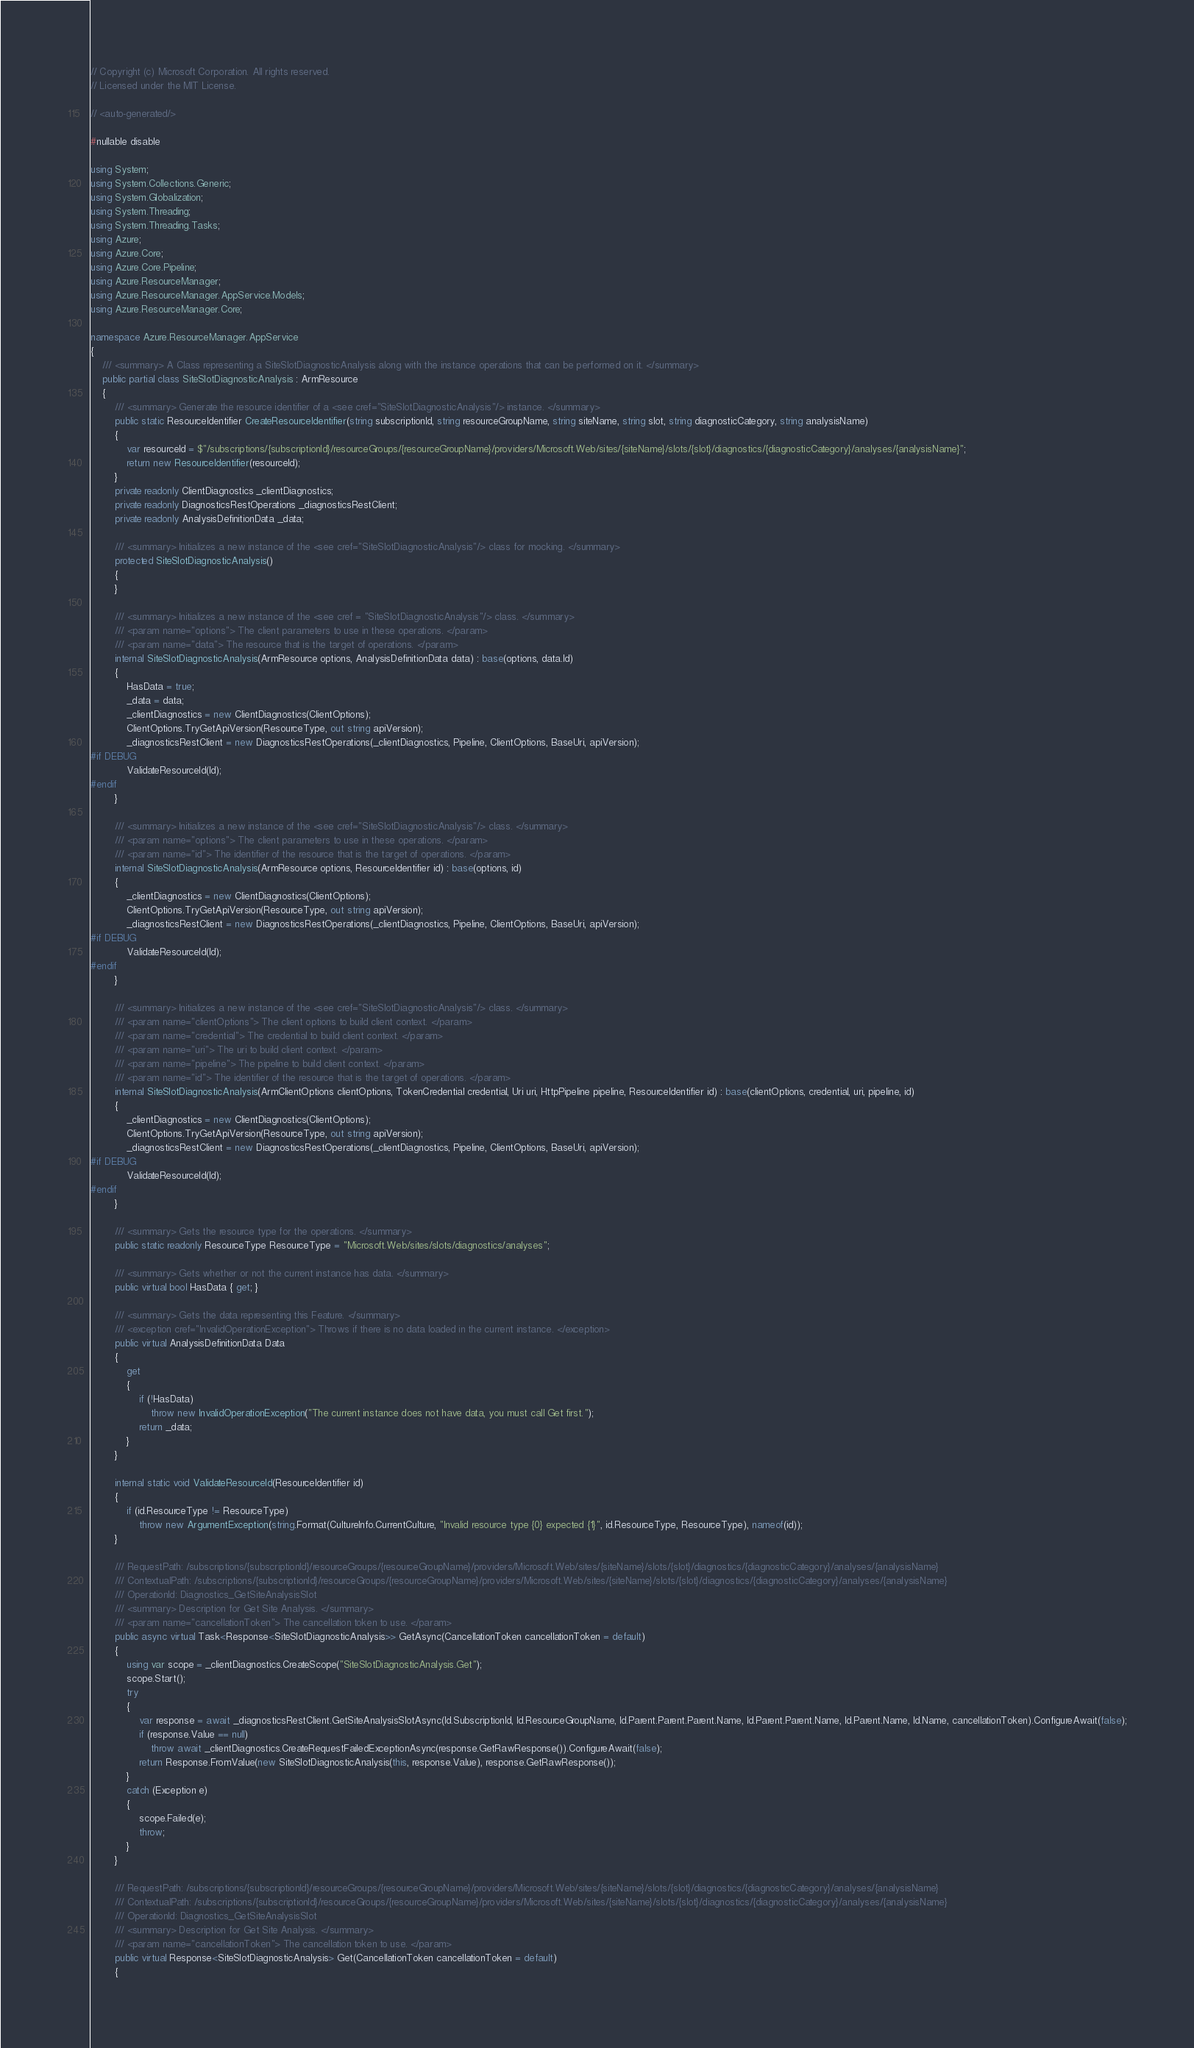<code> <loc_0><loc_0><loc_500><loc_500><_C#_>// Copyright (c) Microsoft Corporation. All rights reserved.
// Licensed under the MIT License.

// <auto-generated/>

#nullable disable

using System;
using System.Collections.Generic;
using System.Globalization;
using System.Threading;
using System.Threading.Tasks;
using Azure;
using Azure.Core;
using Azure.Core.Pipeline;
using Azure.ResourceManager;
using Azure.ResourceManager.AppService.Models;
using Azure.ResourceManager.Core;

namespace Azure.ResourceManager.AppService
{
    /// <summary> A Class representing a SiteSlotDiagnosticAnalysis along with the instance operations that can be performed on it. </summary>
    public partial class SiteSlotDiagnosticAnalysis : ArmResource
    {
        /// <summary> Generate the resource identifier of a <see cref="SiteSlotDiagnosticAnalysis"/> instance. </summary>
        public static ResourceIdentifier CreateResourceIdentifier(string subscriptionId, string resourceGroupName, string siteName, string slot, string diagnosticCategory, string analysisName)
        {
            var resourceId = $"/subscriptions/{subscriptionId}/resourceGroups/{resourceGroupName}/providers/Microsoft.Web/sites/{siteName}/slots/{slot}/diagnostics/{diagnosticCategory}/analyses/{analysisName}";
            return new ResourceIdentifier(resourceId);
        }
        private readonly ClientDiagnostics _clientDiagnostics;
        private readonly DiagnosticsRestOperations _diagnosticsRestClient;
        private readonly AnalysisDefinitionData _data;

        /// <summary> Initializes a new instance of the <see cref="SiteSlotDiagnosticAnalysis"/> class for mocking. </summary>
        protected SiteSlotDiagnosticAnalysis()
        {
        }

        /// <summary> Initializes a new instance of the <see cref = "SiteSlotDiagnosticAnalysis"/> class. </summary>
        /// <param name="options"> The client parameters to use in these operations. </param>
        /// <param name="data"> The resource that is the target of operations. </param>
        internal SiteSlotDiagnosticAnalysis(ArmResource options, AnalysisDefinitionData data) : base(options, data.Id)
        {
            HasData = true;
            _data = data;
            _clientDiagnostics = new ClientDiagnostics(ClientOptions);
            ClientOptions.TryGetApiVersion(ResourceType, out string apiVersion);
            _diagnosticsRestClient = new DiagnosticsRestOperations(_clientDiagnostics, Pipeline, ClientOptions, BaseUri, apiVersion);
#if DEBUG
			ValidateResourceId(Id);
#endif
        }

        /// <summary> Initializes a new instance of the <see cref="SiteSlotDiagnosticAnalysis"/> class. </summary>
        /// <param name="options"> The client parameters to use in these operations. </param>
        /// <param name="id"> The identifier of the resource that is the target of operations. </param>
        internal SiteSlotDiagnosticAnalysis(ArmResource options, ResourceIdentifier id) : base(options, id)
        {
            _clientDiagnostics = new ClientDiagnostics(ClientOptions);
            ClientOptions.TryGetApiVersion(ResourceType, out string apiVersion);
            _diagnosticsRestClient = new DiagnosticsRestOperations(_clientDiagnostics, Pipeline, ClientOptions, BaseUri, apiVersion);
#if DEBUG
			ValidateResourceId(Id);
#endif
        }

        /// <summary> Initializes a new instance of the <see cref="SiteSlotDiagnosticAnalysis"/> class. </summary>
        /// <param name="clientOptions"> The client options to build client context. </param>
        /// <param name="credential"> The credential to build client context. </param>
        /// <param name="uri"> The uri to build client context. </param>
        /// <param name="pipeline"> The pipeline to build client context. </param>
        /// <param name="id"> The identifier of the resource that is the target of operations. </param>
        internal SiteSlotDiagnosticAnalysis(ArmClientOptions clientOptions, TokenCredential credential, Uri uri, HttpPipeline pipeline, ResourceIdentifier id) : base(clientOptions, credential, uri, pipeline, id)
        {
            _clientDiagnostics = new ClientDiagnostics(ClientOptions);
            ClientOptions.TryGetApiVersion(ResourceType, out string apiVersion);
            _diagnosticsRestClient = new DiagnosticsRestOperations(_clientDiagnostics, Pipeline, ClientOptions, BaseUri, apiVersion);
#if DEBUG
			ValidateResourceId(Id);
#endif
        }

        /// <summary> Gets the resource type for the operations. </summary>
        public static readonly ResourceType ResourceType = "Microsoft.Web/sites/slots/diagnostics/analyses";

        /// <summary> Gets whether or not the current instance has data. </summary>
        public virtual bool HasData { get; }

        /// <summary> Gets the data representing this Feature. </summary>
        /// <exception cref="InvalidOperationException"> Throws if there is no data loaded in the current instance. </exception>
        public virtual AnalysisDefinitionData Data
        {
            get
            {
                if (!HasData)
                    throw new InvalidOperationException("The current instance does not have data, you must call Get first.");
                return _data;
            }
        }

        internal static void ValidateResourceId(ResourceIdentifier id)
        {
            if (id.ResourceType != ResourceType)
                throw new ArgumentException(string.Format(CultureInfo.CurrentCulture, "Invalid resource type {0} expected {1}", id.ResourceType, ResourceType), nameof(id));
        }

        /// RequestPath: /subscriptions/{subscriptionId}/resourceGroups/{resourceGroupName}/providers/Microsoft.Web/sites/{siteName}/slots/{slot}/diagnostics/{diagnosticCategory}/analyses/{analysisName}
        /// ContextualPath: /subscriptions/{subscriptionId}/resourceGroups/{resourceGroupName}/providers/Microsoft.Web/sites/{siteName}/slots/{slot}/diagnostics/{diagnosticCategory}/analyses/{analysisName}
        /// OperationId: Diagnostics_GetSiteAnalysisSlot
        /// <summary> Description for Get Site Analysis. </summary>
        /// <param name="cancellationToken"> The cancellation token to use. </param>
        public async virtual Task<Response<SiteSlotDiagnosticAnalysis>> GetAsync(CancellationToken cancellationToken = default)
        {
            using var scope = _clientDiagnostics.CreateScope("SiteSlotDiagnosticAnalysis.Get");
            scope.Start();
            try
            {
                var response = await _diagnosticsRestClient.GetSiteAnalysisSlotAsync(Id.SubscriptionId, Id.ResourceGroupName, Id.Parent.Parent.Parent.Name, Id.Parent.Parent.Name, Id.Parent.Name, Id.Name, cancellationToken).ConfigureAwait(false);
                if (response.Value == null)
                    throw await _clientDiagnostics.CreateRequestFailedExceptionAsync(response.GetRawResponse()).ConfigureAwait(false);
                return Response.FromValue(new SiteSlotDiagnosticAnalysis(this, response.Value), response.GetRawResponse());
            }
            catch (Exception e)
            {
                scope.Failed(e);
                throw;
            }
        }

        /// RequestPath: /subscriptions/{subscriptionId}/resourceGroups/{resourceGroupName}/providers/Microsoft.Web/sites/{siteName}/slots/{slot}/diagnostics/{diagnosticCategory}/analyses/{analysisName}
        /// ContextualPath: /subscriptions/{subscriptionId}/resourceGroups/{resourceGroupName}/providers/Microsoft.Web/sites/{siteName}/slots/{slot}/diagnostics/{diagnosticCategory}/analyses/{analysisName}
        /// OperationId: Diagnostics_GetSiteAnalysisSlot
        /// <summary> Description for Get Site Analysis. </summary>
        /// <param name="cancellationToken"> The cancellation token to use. </param>
        public virtual Response<SiteSlotDiagnosticAnalysis> Get(CancellationToken cancellationToken = default)
        {</code> 